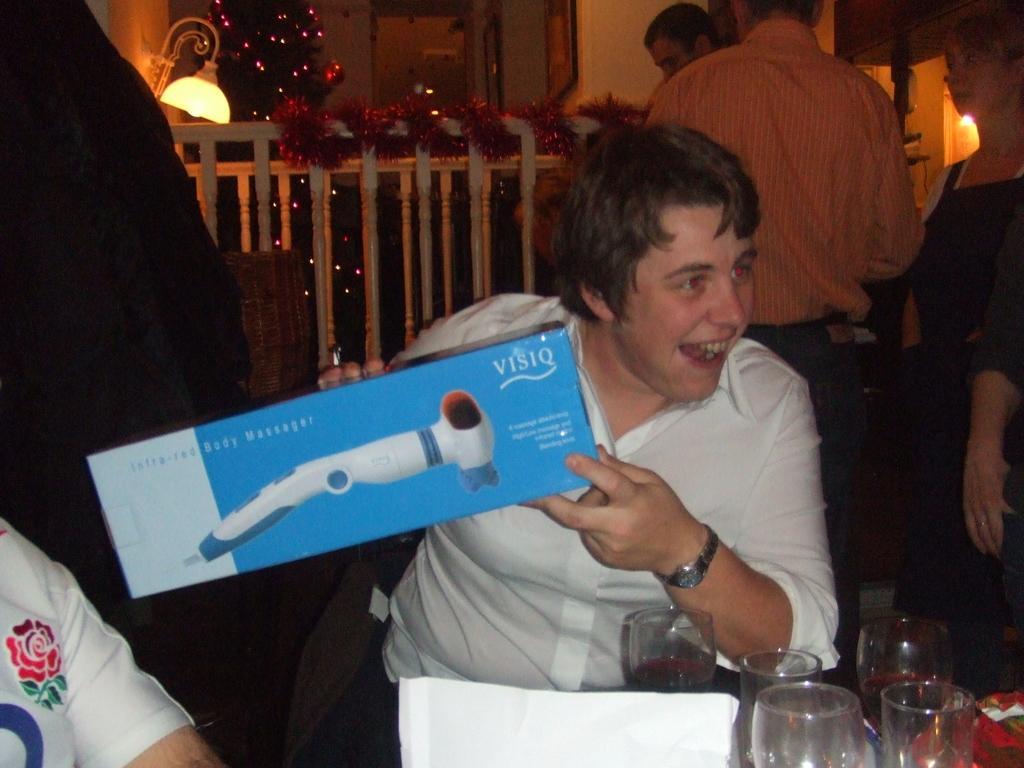Describe this image in one or two sentences. Here we can see a man sitting at the table by holding a box in his hand and on the table we can see glasses,tissue papers and some other items. In the background there are few persons,fence,decorative lights on a tree,frames on the wall and lights. 